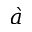<formula> <loc_0><loc_0><loc_500><loc_500>\grave { a }</formula> 